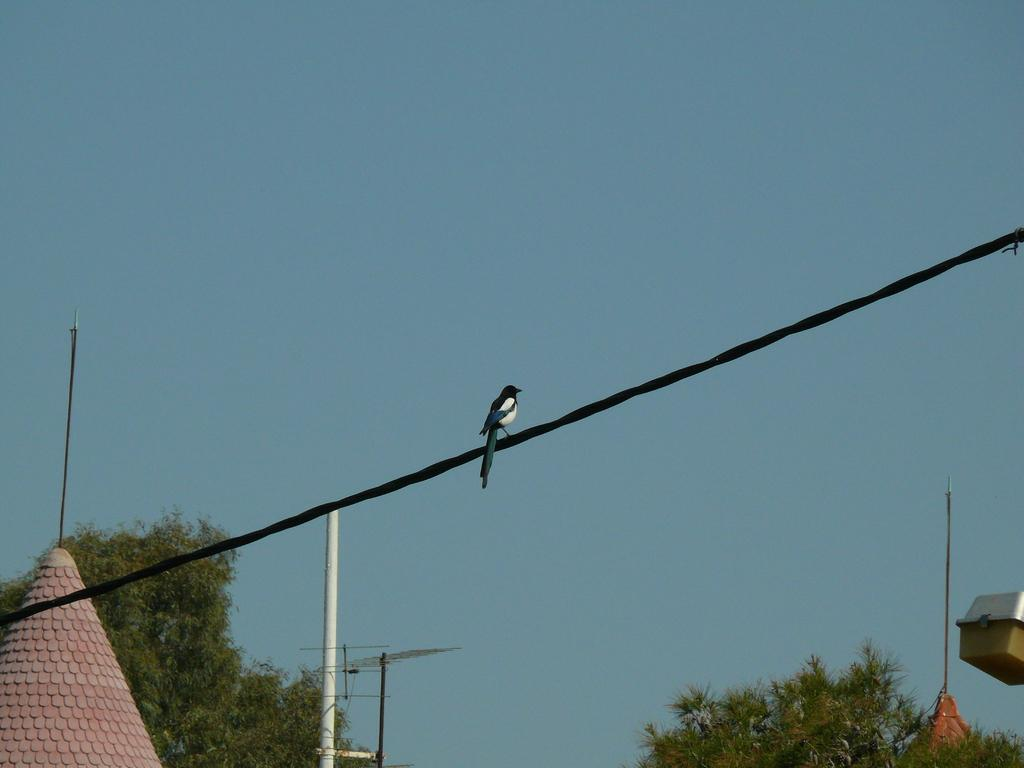What type of structures can be seen in the image? There are upper parts of buildings in the image. What other elements can be seen in the image besides the buildings? There are trees, poles, a bird on a wire, a light, antennas, and the sky visible in the image. What type of attraction is the governor attending in the image? There is no attraction or governor present in the image. What type of machine is being used to maintain the buildings in the image? There is no machine visible in the image; it only shows the upper parts of buildings, trees, poles, a bird on a wire, a light, antennas, and the sky. 